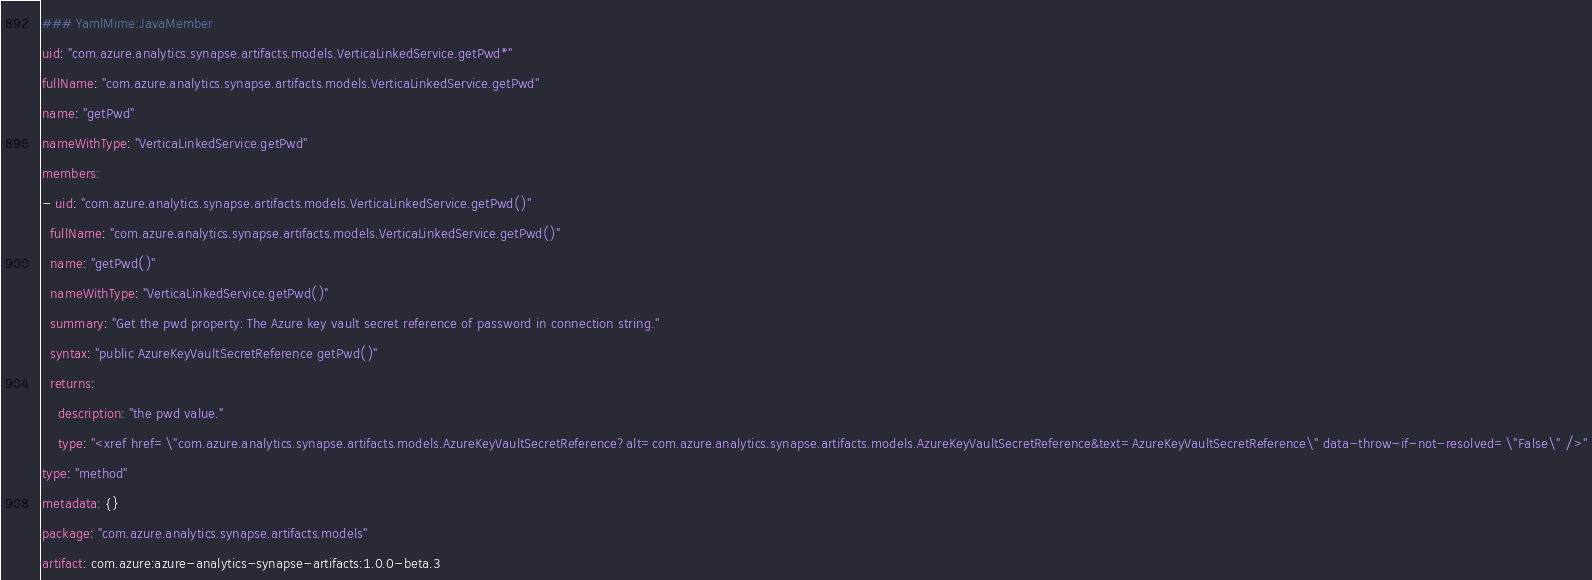<code> <loc_0><loc_0><loc_500><loc_500><_YAML_>### YamlMime:JavaMember
uid: "com.azure.analytics.synapse.artifacts.models.VerticaLinkedService.getPwd*"
fullName: "com.azure.analytics.synapse.artifacts.models.VerticaLinkedService.getPwd"
name: "getPwd"
nameWithType: "VerticaLinkedService.getPwd"
members:
- uid: "com.azure.analytics.synapse.artifacts.models.VerticaLinkedService.getPwd()"
  fullName: "com.azure.analytics.synapse.artifacts.models.VerticaLinkedService.getPwd()"
  name: "getPwd()"
  nameWithType: "VerticaLinkedService.getPwd()"
  summary: "Get the pwd property: The Azure key vault secret reference of password in connection string."
  syntax: "public AzureKeyVaultSecretReference getPwd()"
  returns:
    description: "the pwd value."
    type: "<xref href=\"com.azure.analytics.synapse.artifacts.models.AzureKeyVaultSecretReference?alt=com.azure.analytics.synapse.artifacts.models.AzureKeyVaultSecretReference&text=AzureKeyVaultSecretReference\" data-throw-if-not-resolved=\"False\" />"
type: "method"
metadata: {}
package: "com.azure.analytics.synapse.artifacts.models"
artifact: com.azure:azure-analytics-synapse-artifacts:1.0.0-beta.3
</code> 